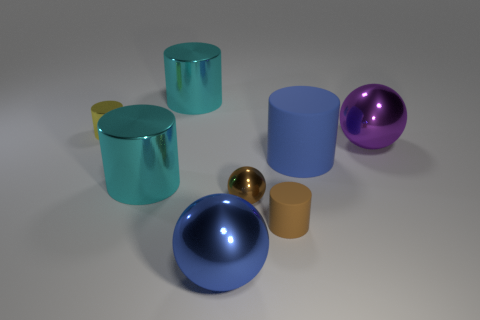Subtract 1 balls. How many balls are left? 2 Subtract all cyan cubes. How many cyan cylinders are left? 2 Subtract all cyan cylinders. How many cylinders are left? 3 Subtract all blue spheres. How many spheres are left? 2 Add 1 tiny things. How many objects exist? 9 Subtract all yellow cylinders. Subtract all gray cubes. How many cylinders are left? 4 Add 7 big purple spheres. How many big purple spheres are left? 8 Add 7 big purple metal balls. How many big purple metal balls exist? 8 Subtract 0 purple cylinders. How many objects are left? 8 Subtract all spheres. How many objects are left? 5 